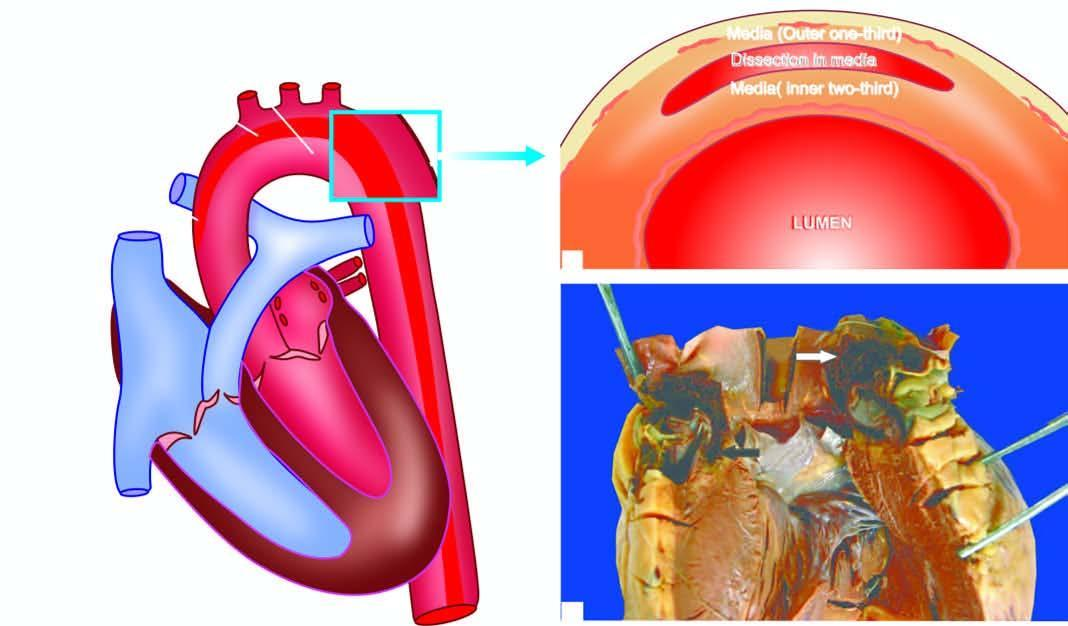where is an intimal tear seen?
Answer the question using a single word or phrase. In the arch 